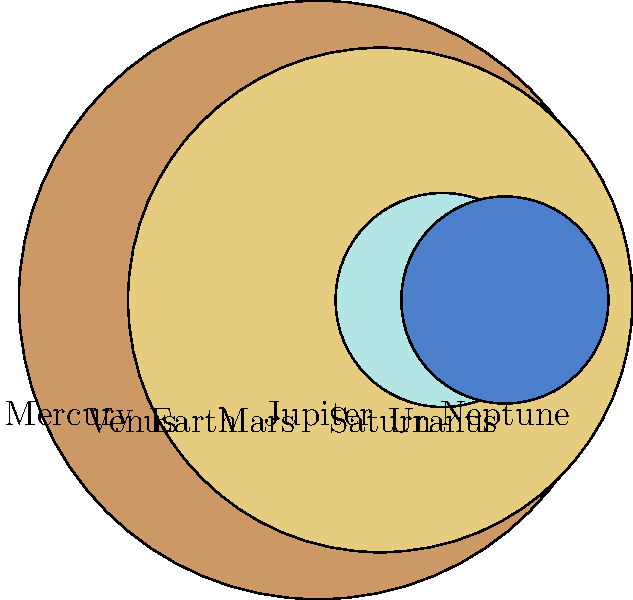During a stargazing event at Lettuce Lake Park in Tampa, you notice a diagram showing the relative sizes of planets in our Solar System. Which planet is approximately 11 times larger than Earth in diameter? To answer this question, let's analyze the diagram step-by-step:

1. The diagram shows the relative sizes of the eight planets in our Solar System.
2. Each planet is represented by a colored circle, with its name labeled below.
3. The sizes are proportional to each other, with Earth serving as a reference point.
4. We need to find a planet that is about 11 times larger than Earth in diameter.

5. Looking at the relative sizes:
   - Mercury, Venus, Earth, and Mars are noticeably smaller.
   - Uranus and Neptune are larger than Earth but not by a factor of 11.
   - Saturn is significantly larger than Earth but not quite 11 times.
   - Jupiter stands out as the largest planet, visibly much larger than Earth.

6. To confirm, we can check the relative sizes:
   - Earth's size is represented as 1 (our reference point).
   - Jupiter's size is given as 11.21 times that of Earth.

7. This matches our observation and the question's requirement of "approximately 11 times larger than Earth in diameter."

Therefore, Jupiter is the planet that is approximately 11 times larger than Earth in diameter.
Answer: Jupiter 